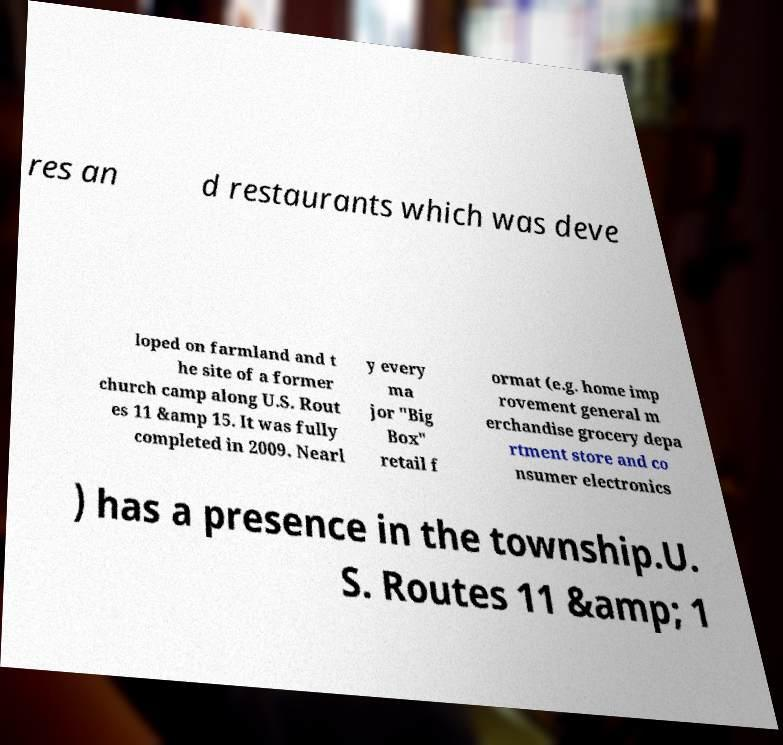I need the written content from this picture converted into text. Can you do that? res an d restaurants which was deve loped on farmland and t he site of a former church camp along U.S. Rout es 11 &amp 15. It was fully completed in 2009. Nearl y every ma jor "Big Box" retail f ormat (e.g. home imp rovement general m erchandise grocery depa rtment store and co nsumer electronics ) has a presence in the township.U. S. Routes 11 &amp; 1 